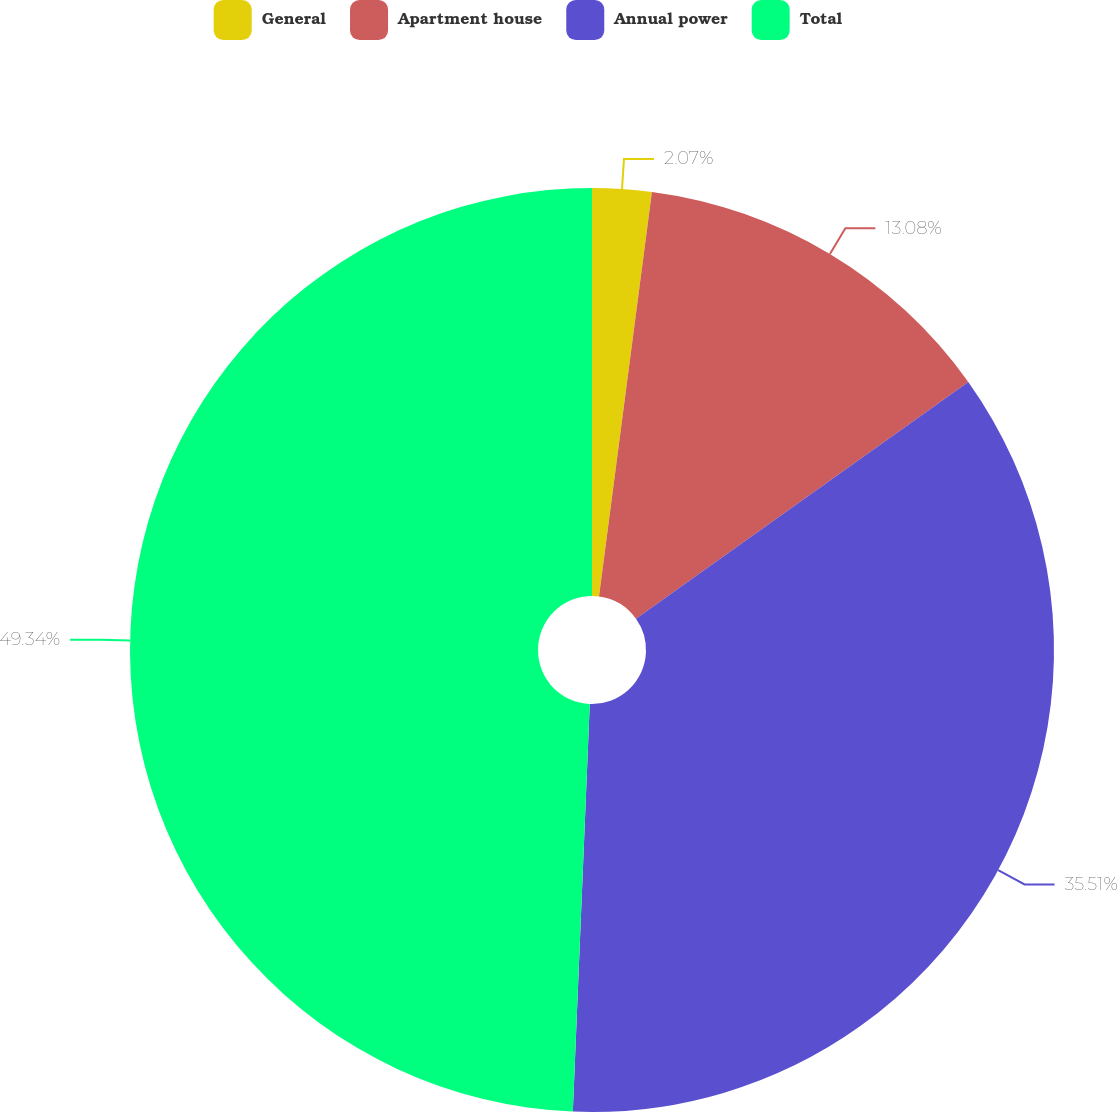Convert chart. <chart><loc_0><loc_0><loc_500><loc_500><pie_chart><fcel>General<fcel>Apartment house<fcel>Annual power<fcel>Total<nl><fcel>2.07%<fcel>13.08%<fcel>35.51%<fcel>49.34%<nl></chart> 